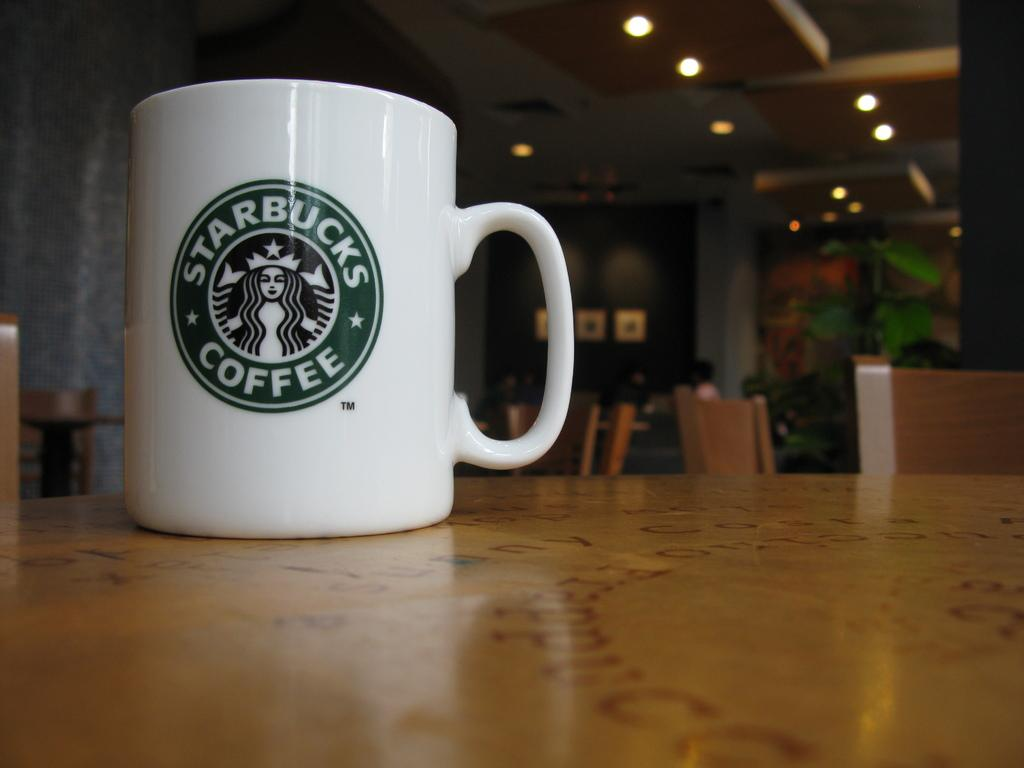Provide a one-sentence caption for the provided image. a Starbuck Coffee mug logo on a table top. 